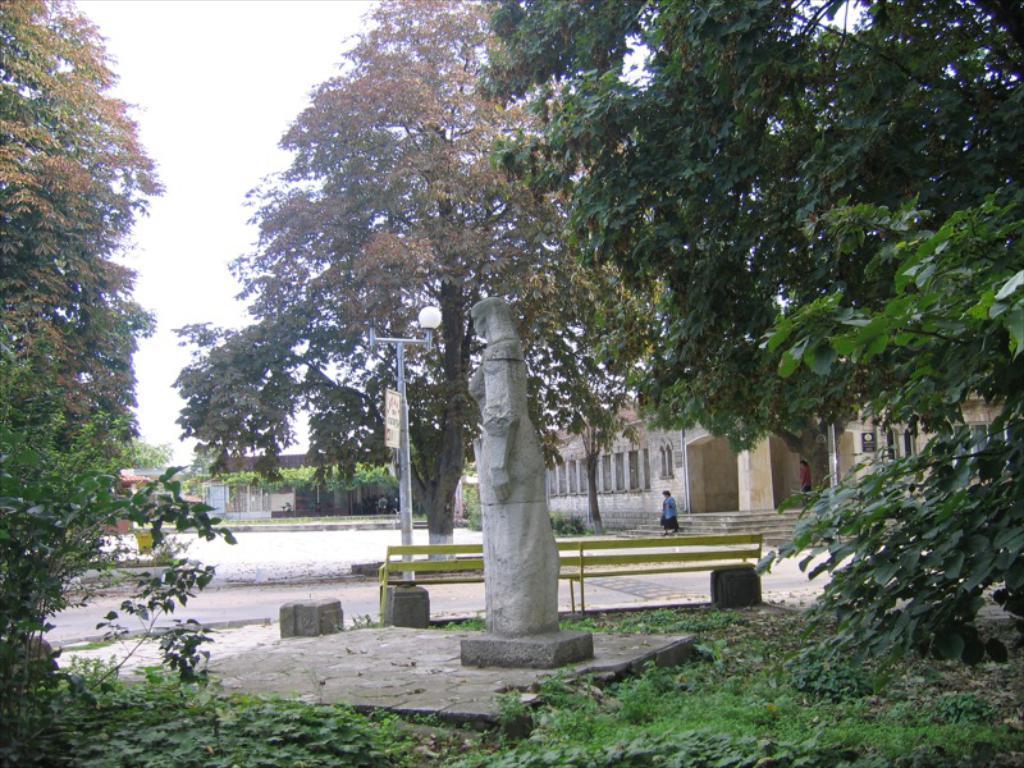Describe this image in one or two sentences. In this picture there is a statue in the center of the image and there is a lamp pole and a bench behind the statue, there are houses and people in the background area of the image and there is greenery in the image. 